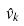Convert formula to latex. <formula><loc_0><loc_0><loc_500><loc_500>\hat { v } _ { k }</formula> 